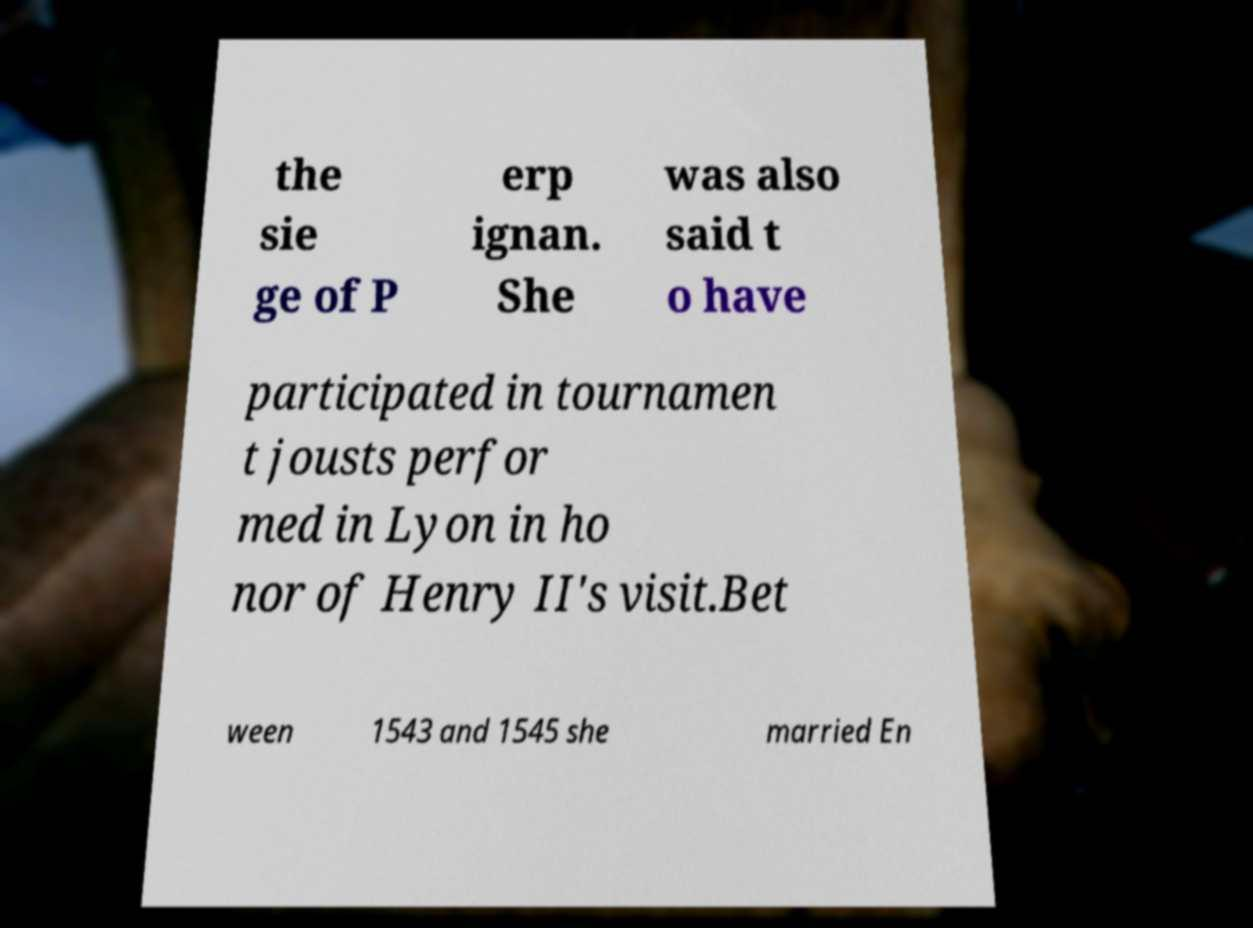Can you accurately transcribe the text from the provided image for me? the sie ge of P erp ignan. She was also said t o have participated in tournamen t jousts perfor med in Lyon in ho nor of Henry II's visit.Bet ween 1543 and 1545 she married En 